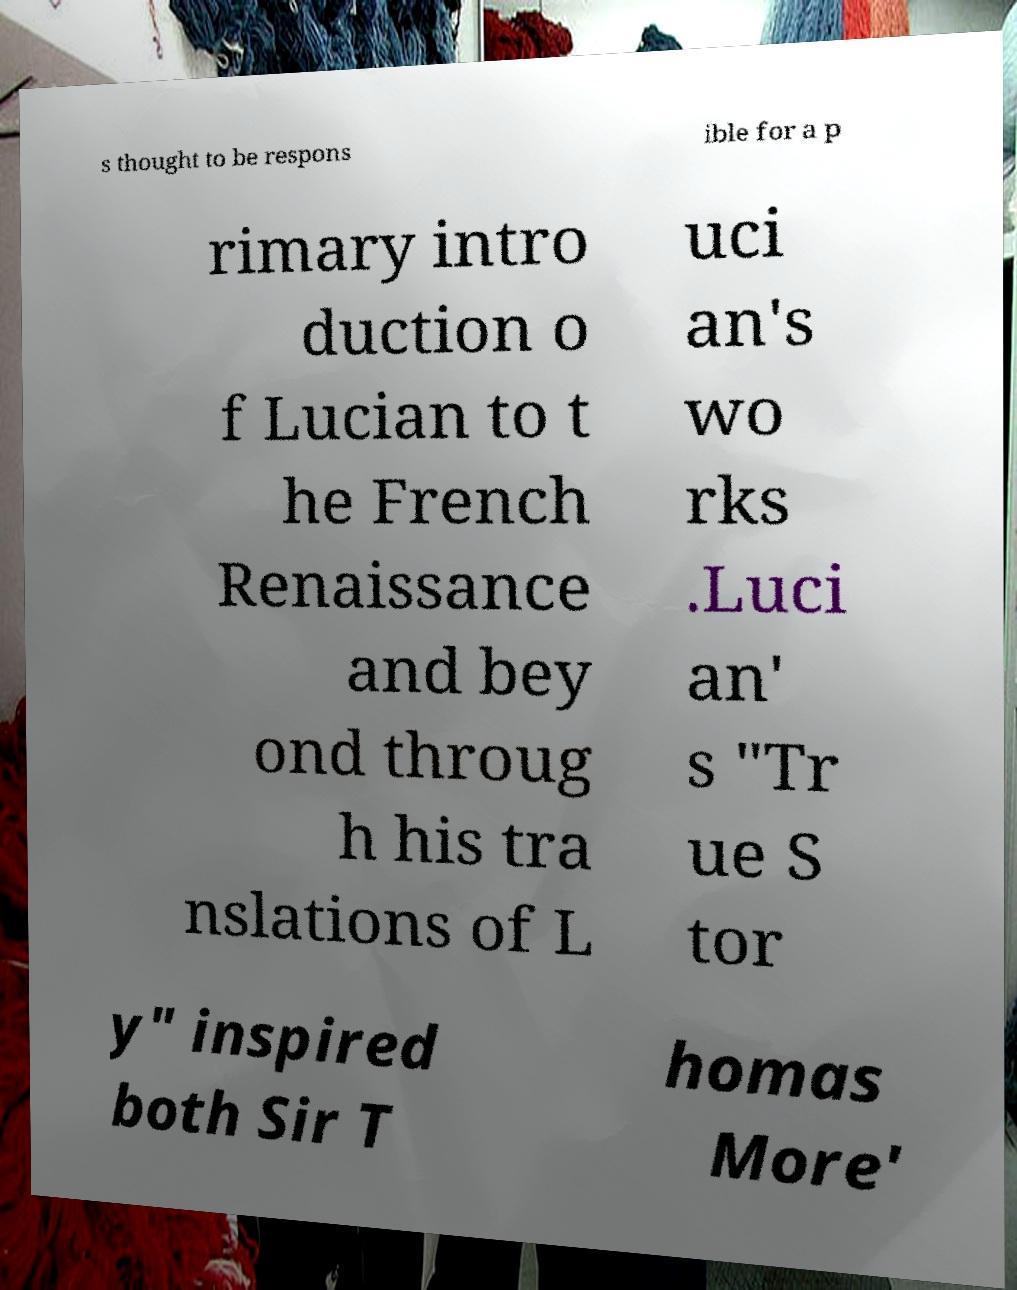For documentation purposes, I need the text within this image transcribed. Could you provide that? s thought to be respons ible for a p rimary intro duction o f Lucian to t he French Renaissance and bey ond throug h his tra nslations of L uci an's wo rks .Luci an' s "Tr ue S tor y" inspired both Sir T homas More' 